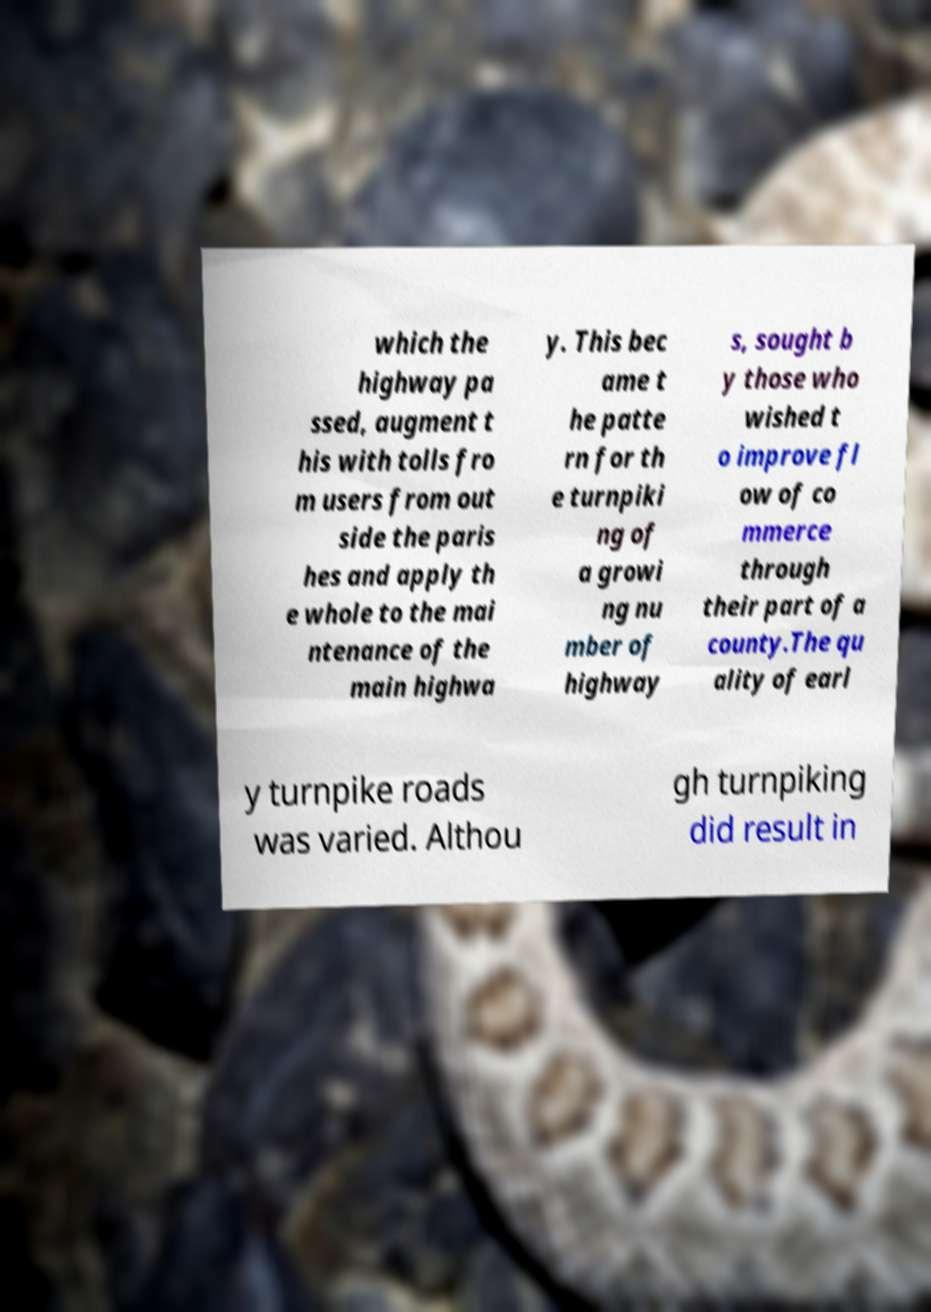Please read and relay the text visible in this image. What does it say? which the highway pa ssed, augment t his with tolls fro m users from out side the paris hes and apply th e whole to the mai ntenance of the main highwa y. This bec ame t he patte rn for th e turnpiki ng of a growi ng nu mber of highway s, sought b y those who wished t o improve fl ow of co mmerce through their part of a county.The qu ality of earl y turnpike roads was varied. Althou gh turnpiking did result in 